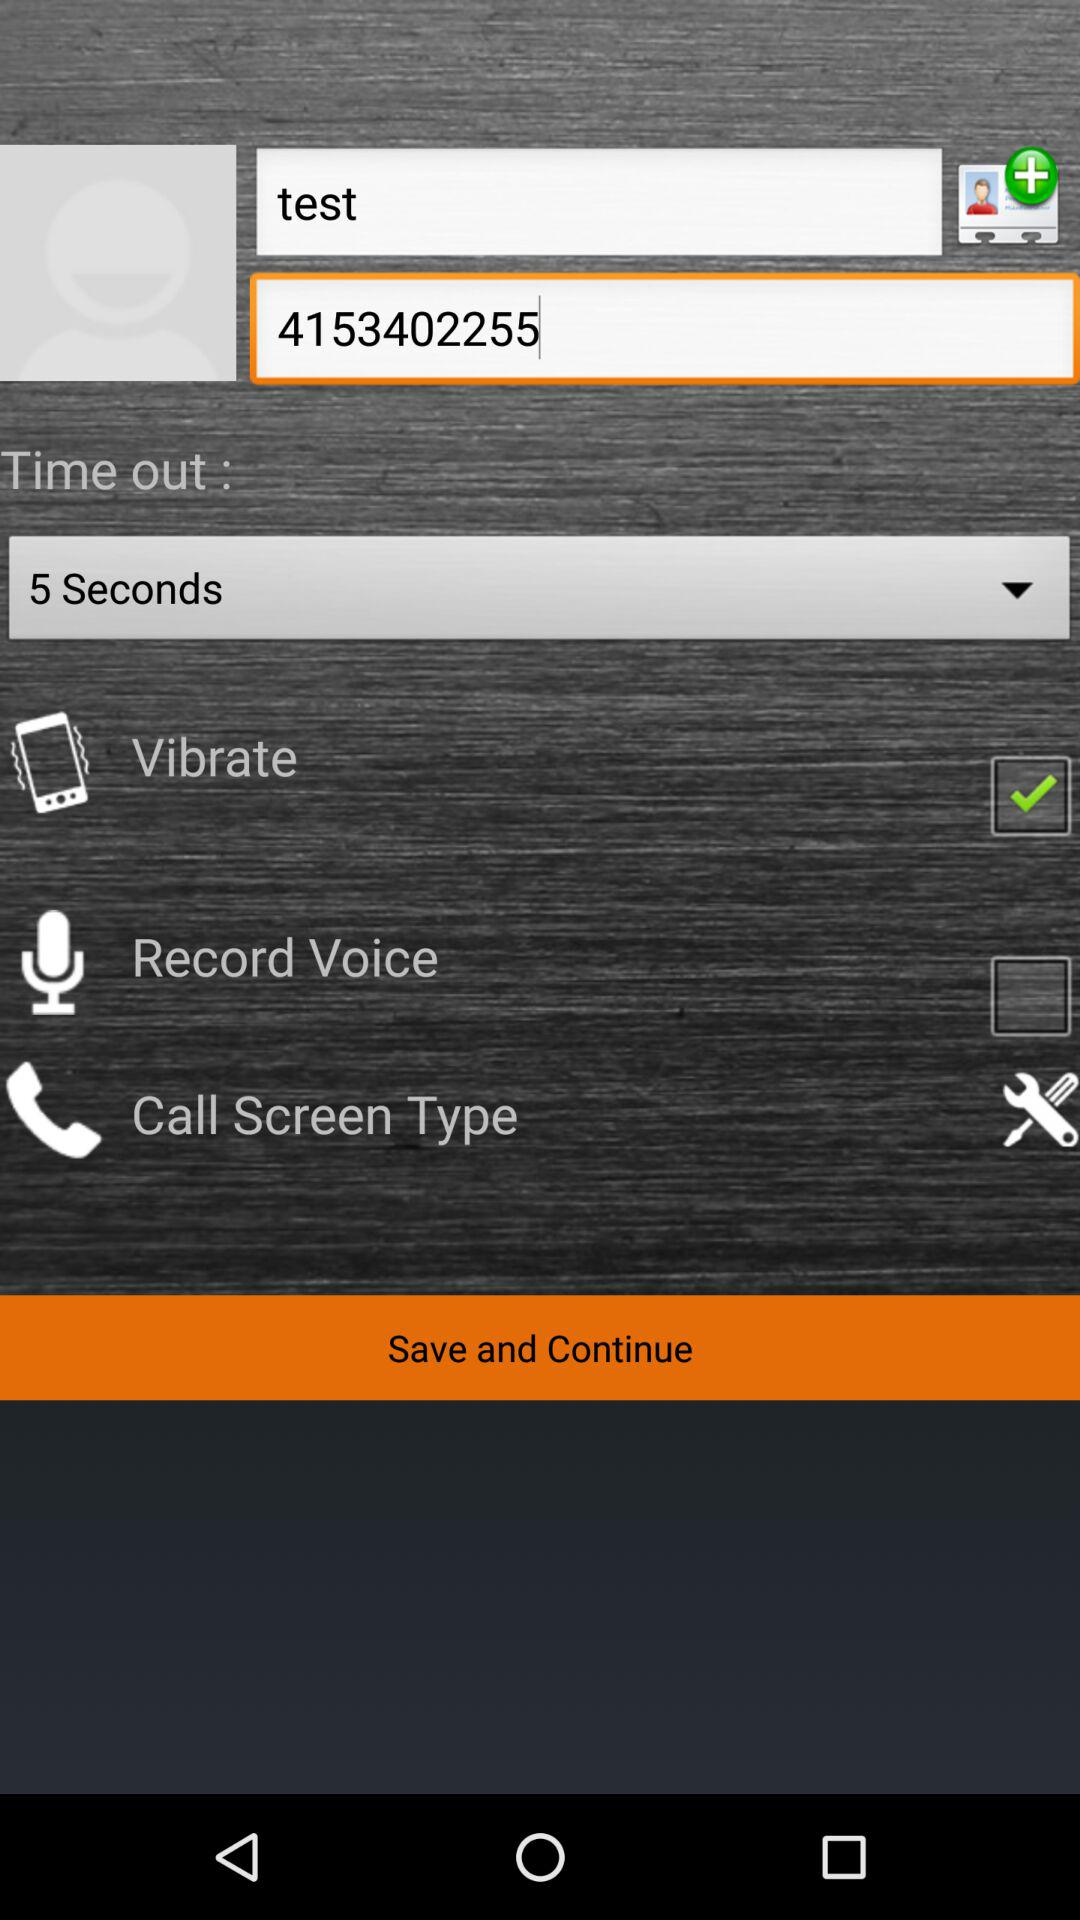What options are selected? The selected option is "5 Seconds". 